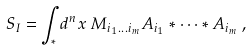<formula> <loc_0><loc_0><loc_500><loc_500>S _ { I } = \int _ { * } d ^ { n } x \, M _ { i _ { 1 } \dots i _ { m } } A _ { i _ { 1 } } * \cdots * A _ { i _ { m } } \, ,</formula> 